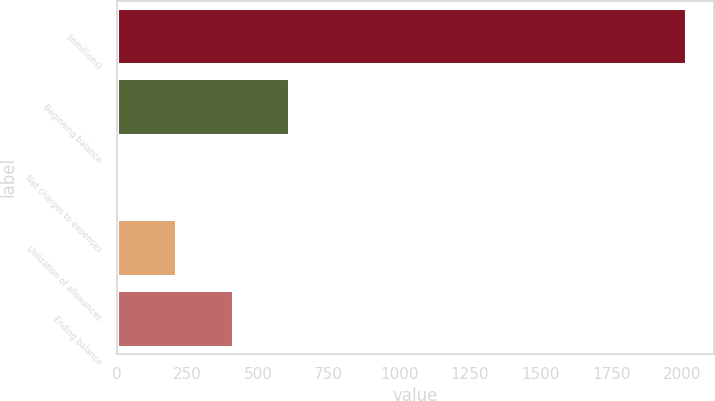<chart> <loc_0><loc_0><loc_500><loc_500><bar_chart><fcel>(inmillions)<fcel>Beginning balance<fcel>Net charges to expenses<fcel>Utilization of allowances<fcel>Ending balance<nl><fcel>2014<fcel>611.2<fcel>10<fcel>210.4<fcel>410.8<nl></chart> 